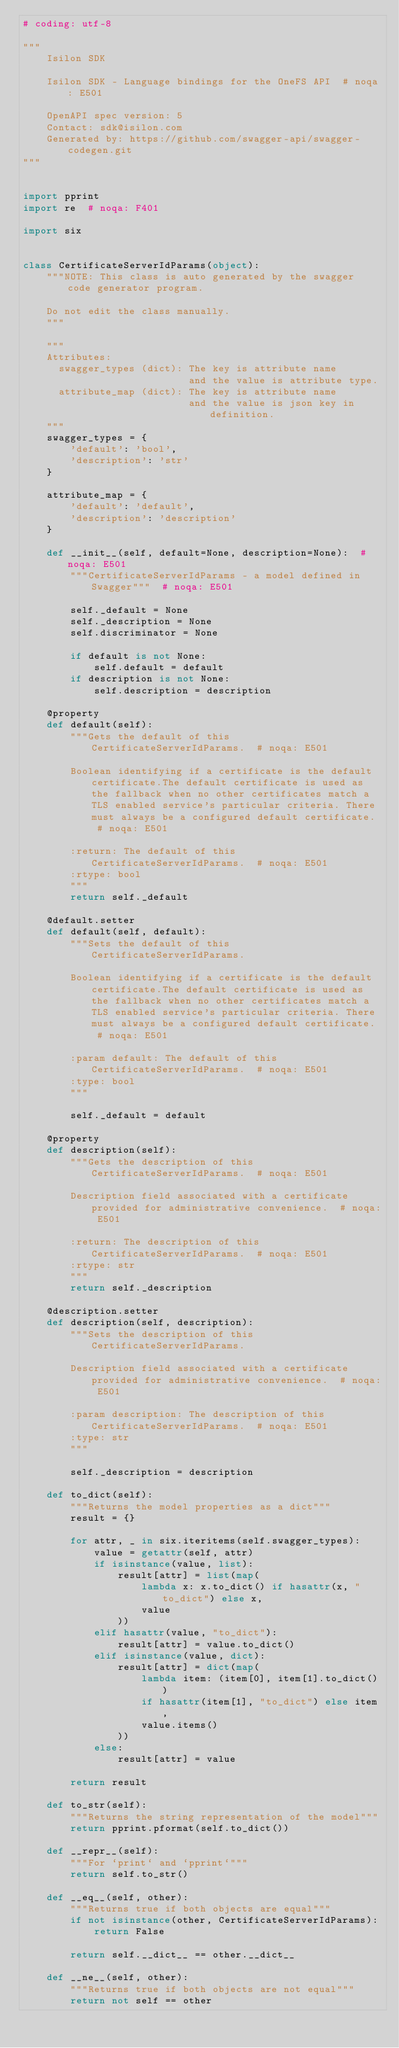<code> <loc_0><loc_0><loc_500><loc_500><_Python_># coding: utf-8

"""
    Isilon SDK

    Isilon SDK - Language bindings for the OneFS API  # noqa: E501

    OpenAPI spec version: 5
    Contact: sdk@isilon.com
    Generated by: https://github.com/swagger-api/swagger-codegen.git
"""


import pprint
import re  # noqa: F401

import six


class CertificateServerIdParams(object):
    """NOTE: This class is auto generated by the swagger code generator program.

    Do not edit the class manually.
    """

    """
    Attributes:
      swagger_types (dict): The key is attribute name
                            and the value is attribute type.
      attribute_map (dict): The key is attribute name
                            and the value is json key in definition.
    """
    swagger_types = {
        'default': 'bool',
        'description': 'str'
    }

    attribute_map = {
        'default': 'default',
        'description': 'description'
    }

    def __init__(self, default=None, description=None):  # noqa: E501
        """CertificateServerIdParams - a model defined in Swagger"""  # noqa: E501

        self._default = None
        self._description = None
        self.discriminator = None

        if default is not None:
            self.default = default
        if description is not None:
            self.description = description

    @property
    def default(self):
        """Gets the default of this CertificateServerIdParams.  # noqa: E501

        Boolean identifying if a certificate is the default certificate.The default certificate is used as the fallback when no other certificates match a TLS enabled service's particular criteria. There must always be a configured default certificate.  # noqa: E501

        :return: The default of this CertificateServerIdParams.  # noqa: E501
        :rtype: bool
        """
        return self._default

    @default.setter
    def default(self, default):
        """Sets the default of this CertificateServerIdParams.

        Boolean identifying if a certificate is the default certificate.The default certificate is used as the fallback when no other certificates match a TLS enabled service's particular criteria. There must always be a configured default certificate.  # noqa: E501

        :param default: The default of this CertificateServerIdParams.  # noqa: E501
        :type: bool
        """

        self._default = default

    @property
    def description(self):
        """Gets the description of this CertificateServerIdParams.  # noqa: E501

        Description field associated with a certificate provided for administrative convenience.  # noqa: E501

        :return: The description of this CertificateServerIdParams.  # noqa: E501
        :rtype: str
        """
        return self._description

    @description.setter
    def description(self, description):
        """Sets the description of this CertificateServerIdParams.

        Description field associated with a certificate provided for administrative convenience.  # noqa: E501

        :param description: The description of this CertificateServerIdParams.  # noqa: E501
        :type: str
        """

        self._description = description

    def to_dict(self):
        """Returns the model properties as a dict"""
        result = {}

        for attr, _ in six.iteritems(self.swagger_types):
            value = getattr(self, attr)
            if isinstance(value, list):
                result[attr] = list(map(
                    lambda x: x.to_dict() if hasattr(x, "to_dict") else x,
                    value
                ))
            elif hasattr(value, "to_dict"):
                result[attr] = value.to_dict()
            elif isinstance(value, dict):
                result[attr] = dict(map(
                    lambda item: (item[0], item[1].to_dict())
                    if hasattr(item[1], "to_dict") else item,
                    value.items()
                ))
            else:
                result[attr] = value

        return result

    def to_str(self):
        """Returns the string representation of the model"""
        return pprint.pformat(self.to_dict())

    def __repr__(self):
        """For `print` and `pprint`"""
        return self.to_str()

    def __eq__(self, other):
        """Returns true if both objects are equal"""
        if not isinstance(other, CertificateServerIdParams):
            return False

        return self.__dict__ == other.__dict__

    def __ne__(self, other):
        """Returns true if both objects are not equal"""
        return not self == other
</code> 